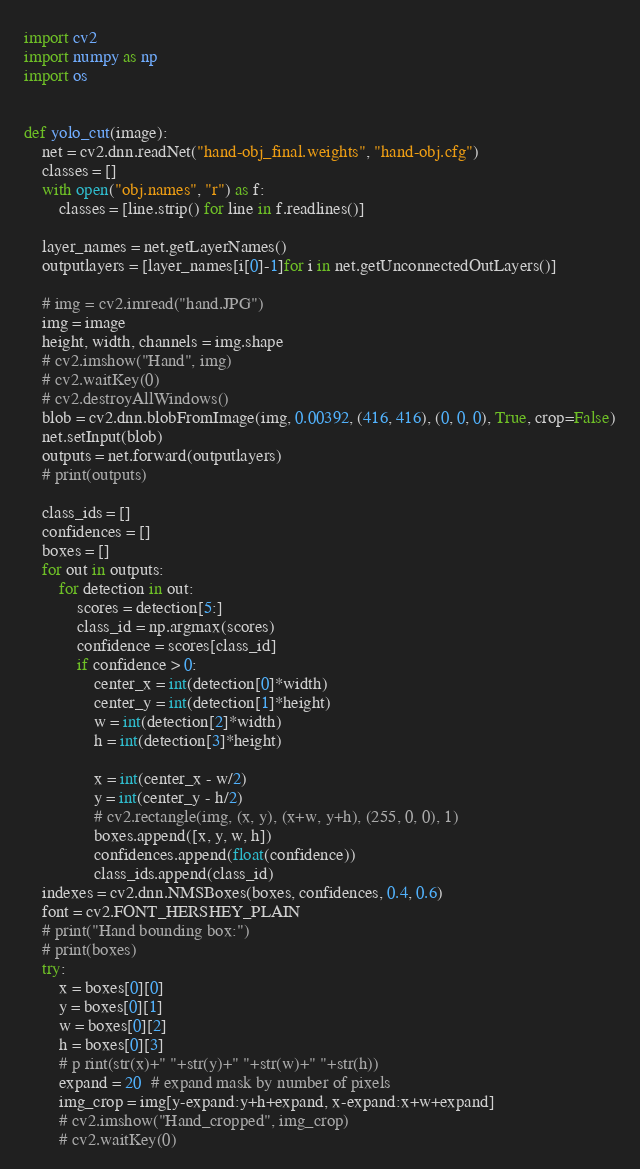Convert code to text. <code><loc_0><loc_0><loc_500><loc_500><_Python_>import cv2
import numpy as np
import os


def yolo_cut(image):
    net = cv2.dnn.readNet("hand-obj_final.weights", "hand-obj.cfg")
    classes = []
    with open("obj.names", "r") as f:
        classes = [line.strip() for line in f.readlines()]

    layer_names = net.getLayerNames()
    outputlayers = [layer_names[i[0]-1]for i in net.getUnconnectedOutLayers()]

    # img = cv2.imread("hand.JPG")
    img = image
    height, width, channels = img.shape
    # cv2.imshow("Hand", img)
    # cv2.waitKey(0)
    # cv2.destroyAllWindows()
    blob = cv2.dnn.blobFromImage(img, 0.00392, (416, 416), (0, 0, 0), True, crop=False)
    net.setInput(blob)
    outputs = net.forward(outputlayers)
    # print(outputs)

    class_ids = []
    confidences = []
    boxes = []
    for out in outputs:
        for detection in out:
            scores = detection[5:]
            class_id = np.argmax(scores)
            confidence = scores[class_id]
            if confidence > 0:
                center_x = int(detection[0]*width)
                center_y = int(detection[1]*height)
                w = int(detection[2]*width)
                h = int(detection[3]*height)

                x = int(center_x - w/2)
                y = int(center_y - h/2)
                # cv2.rectangle(img, (x, y), (x+w, y+h), (255, 0, 0), 1)
                boxes.append([x, y, w, h])
                confidences.append(float(confidence))
                class_ids.append(class_id)
    indexes = cv2.dnn.NMSBoxes(boxes, confidences, 0.4, 0.6)
    font = cv2.FONT_HERSHEY_PLAIN
    # print("Hand bounding box:")
    # print(boxes)
    try:
        x = boxes[0][0]
        y = boxes[0][1]
        w = boxes[0][2]
        h = boxes[0][3]
        # p rint(str(x)+" "+str(y)+" "+str(w)+" "+str(h))
        expand = 20  # expand mask by number of pixels
        img_crop = img[y-expand:y+h+expand, x-expand:x+w+expand]
        # cv2.imshow("Hand_cropped", img_crop)
        # cv2.waitKey(0)</code> 